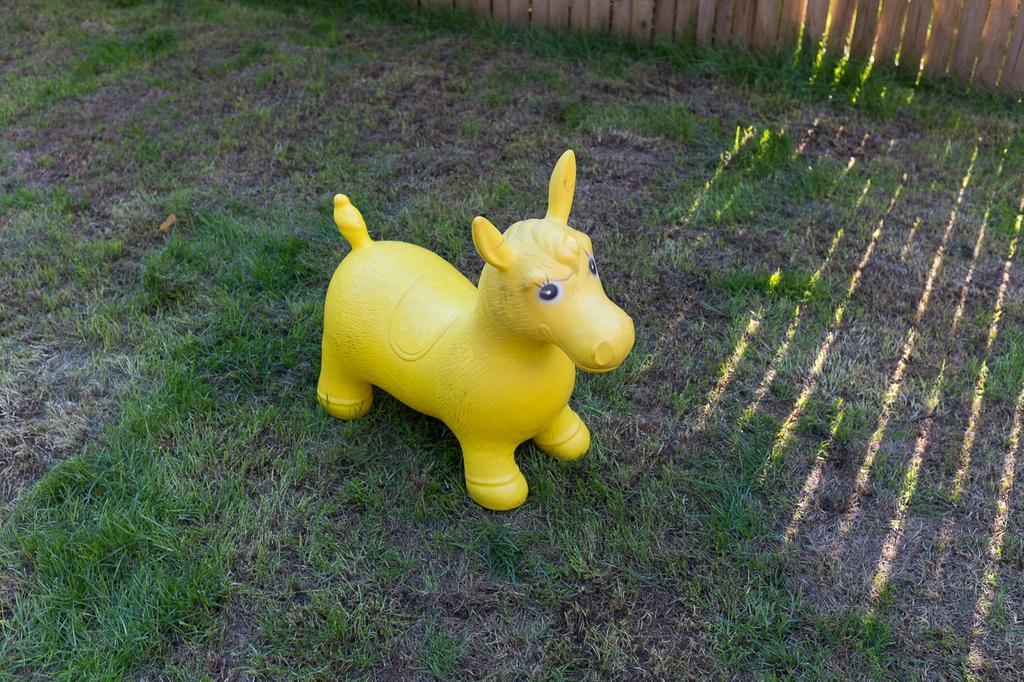Please provide a concise description of this image. In this image we can see there is a toy on the surface of the grass. At the top of the image there is wooden fencing. 